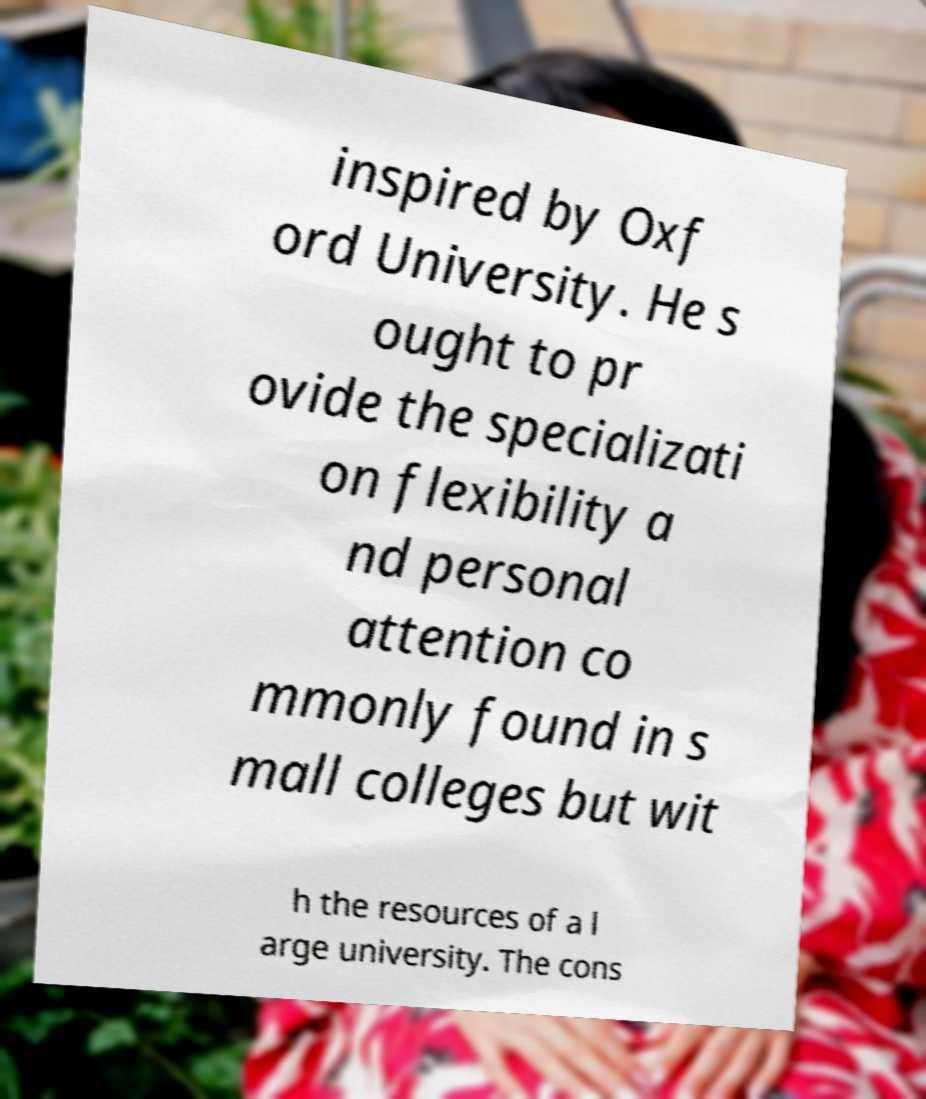I need the written content from this picture converted into text. Can you do that? inspired by Oxf ord University. He s ought to pr ovide the specializati on flexibility a nd personal attention co mmonly found in s mall colleges but wit h the resources of a l arge university. The cons 